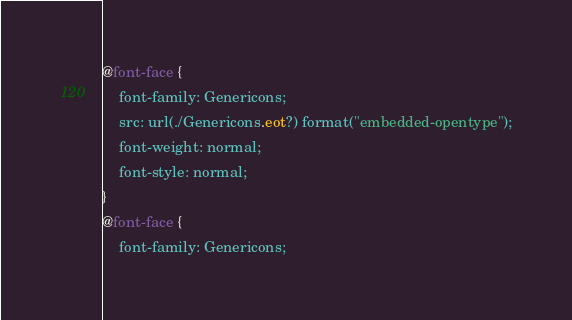<code> <loc_0><loc_0><loc_500><loc_500><_CSS_>@font-face {
	font-family: Genericons;
	src: url(./Genericons.eot?) format("embedded-opentype");
	font-weight: normal;
	font-style: normal;
}
@font-face {
	font-family: Genericons;</code> 